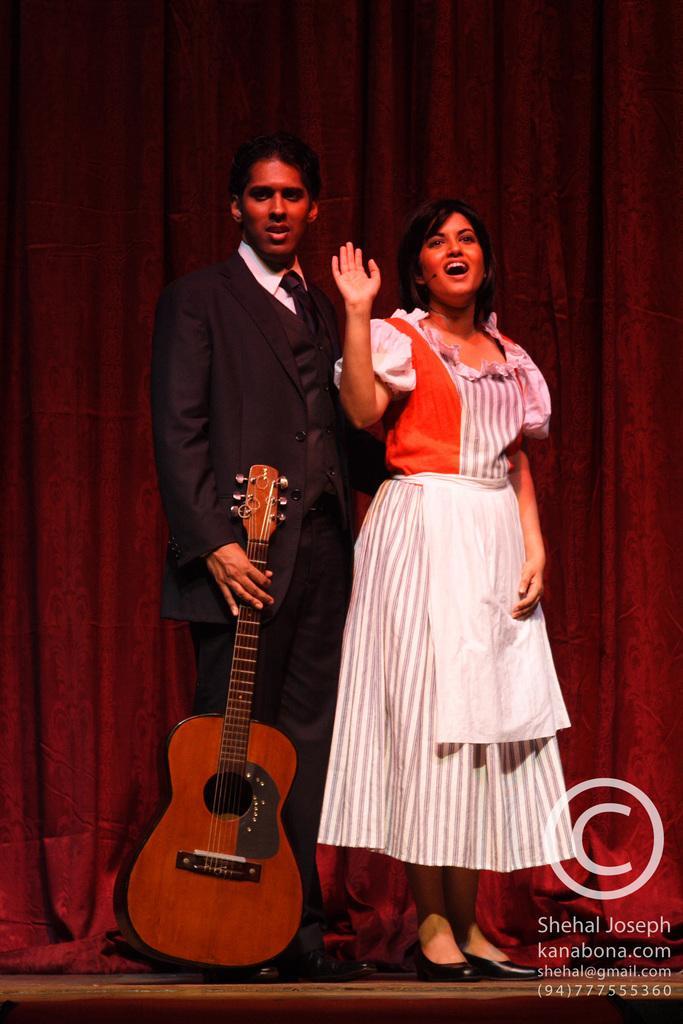How would you summarize this image in a sentence or two? In this image i can see man and a woman standing, the man is holding a guitar. In the background i can see a red curtain. 